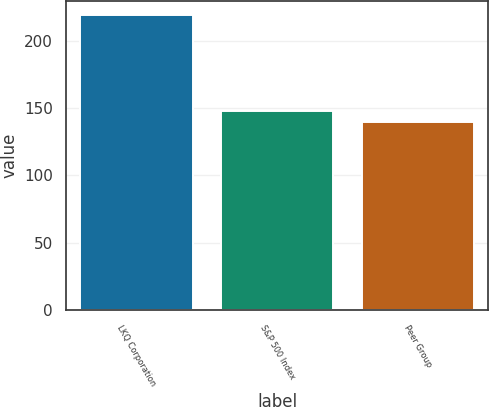Convert chart to OTSL. <chart><loc_0><loc_0><loc_500><loc_500><bar_chart><fcel>LKQ Corporation<fcel>S&P 500 Index<fcel>Peer Group<nl><fcel>219<fcel>147.9<fcel>140<nl></chart> 